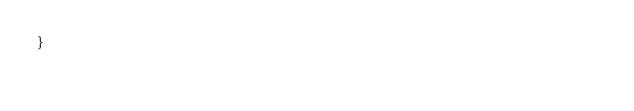Convert code to text. <code><loc_0><loc_0><loc_500><loc_500><_Awk_>}
      
</code> 